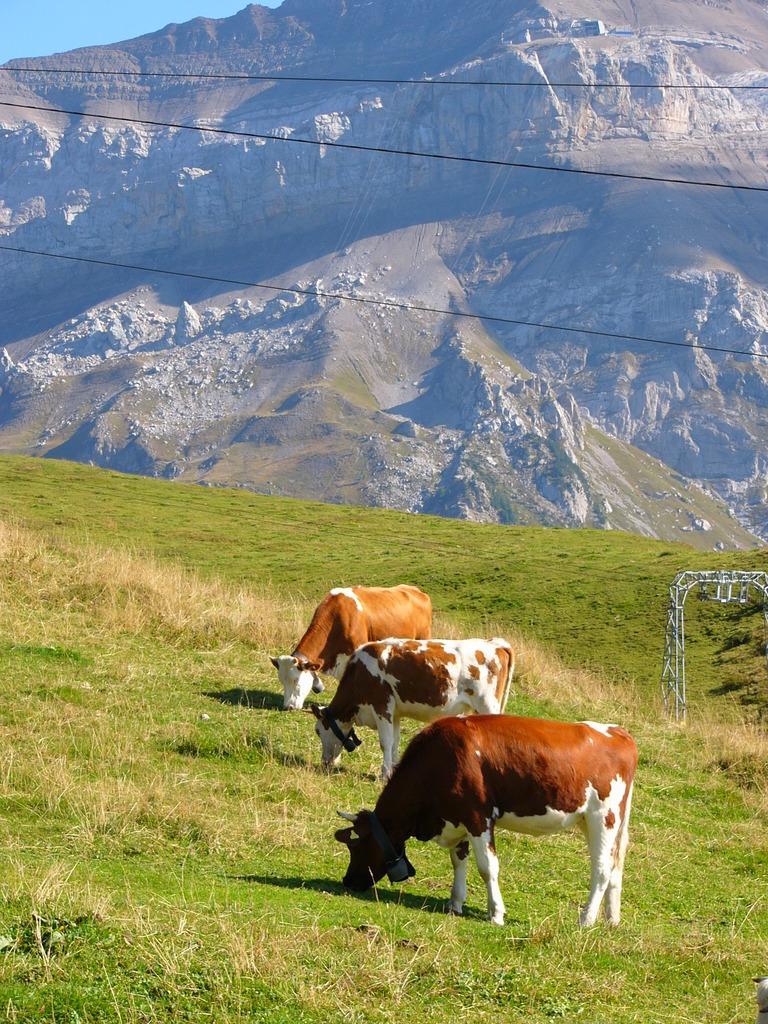Please provide a concise description of this image. There are three cows which are eating the grass. In the background there are hills on which there are stones. At the top there are wires. 